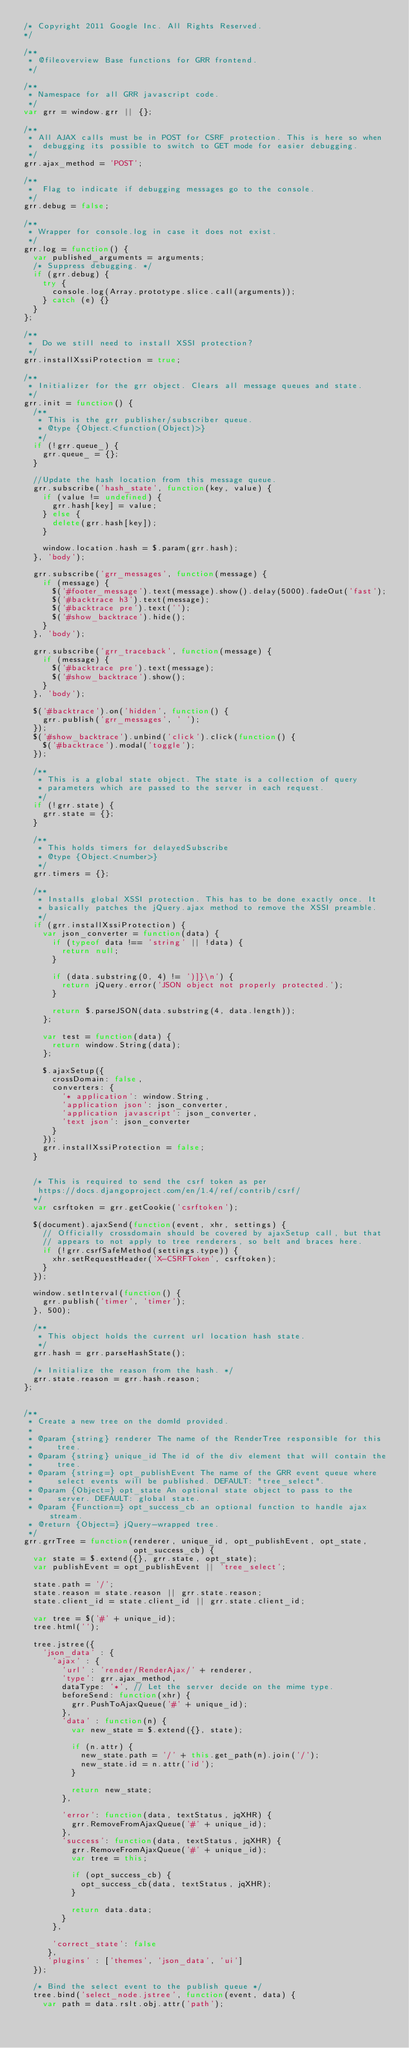<code> <loc_0><loc_0><loc_500><loc_500><_JavaScript_>/* Copyright 2011 Google Inc. All Rights Reserved.
*/

/**
 * @fileoverview Base functions for GRR frontend.
 */

/**
 * Namespace for all GRR javascript code.
 */
var grr = window.grr || {};

/**
 * All AJAX calls must be in POST for CSRF protection. This is here so when
 *  debugging its possible to switch to GET mode for easier debugging.
 */
grr.ajax_method = 'POST';

/**
 *  Flag to indicate if debugging messages go to the console.
 */
grr.debug = false;

/**
 * Wrapper for console.log in case it does not exist.
 */
grr.log = function() {
  var published_arguments = arguments;
  /* Suppress debugging. */
  if (grr.debug) {
    try {
      console.log(Array.prototype.slice.call(arguments));
    } catch (e) {}
  }
};

/**
 *  Do we still need to install XSSI protection?
 */
grr.installXssiProtection = true;

/**
 * Initializer for the grr object. Clears all message queues and state.
 */
grr.init = function() {
  /**
   * This is the grr publisher/subscriber queue.
   * @type {Object.<function(Object)>}
   */
  if (!grr.queue_) {
    grr.queue_ = {};
  }

  //Update the hash location from this message queue.
  grr.subscribe('hash_state', function(key, value) {
    if (value != undefined) {
      grr.hash[key] = value;
    } else {
      delete(grr.hash[key]);
    }

    window.location.hash = $.param(grr.hash);
  }, 'body');

  grr.subscribe('grr_messages', function(message) {
    if (message) {
      $('#footer_message').text(message).show().delay(5000).fadeOut('fast');
      $('#backtrace h3').text(message);
      $('#backtrace pre').text('');
      $('#show_backtrace').hide();
    }
  }, 'body');

  grr.subscribe('grr_traceback', function(message) {
    if (message) {
      $('#backtrace pre').text(message);
      $('#show_backtrace').show();
    }
  }, 'body');

  $('#backtrace').on('hidden', function() {
    grr.publish('grr_messages', ' ');
  });
  $('#show_backtrace').unbind('click').click(function() {
    $('#backtrace').modal('toggle');
  });

  /**
   * This is a global state object. The state is a collection of query
   * parameters which are passed to the server in each request.
   */
  if (!grr.state) {
    grr.state = {};
  }

  /**
   * This holds timers for delayedSubscribe
   * @type {Object.<number>}
   */
  grr.timers = {};

  /**
   * Installs global XSSI protection. This has to be done exactly once. It
   * basically patches the jQuery.ajax method to remove the XSSI preamble.
   */
  if (grr.installXssiProtection) {
    var json_converter = function(data) {
      if (typeof data !== 'string' || !data) {
        return null;
      }

      if (data.substring(0, 4) != ')]}\n') {
        return jQuery.error('JSON object not properly protected.');
      }

      return $.parseJSON(data.substring(4, data.length));
    };

    var test = function(data) {
      return window.String(data);
    };

    $.ajaxSetup({
      crossDomain: false,
      converters: {
        '* application': window.String,
        'application json': json_converter,
        'application javascript': json_converter,
        'text json': json_converter
      }
    });
    grr.installXssiProtection = false;
  }


  /* This is required to send the csrf token as per
   https://docs.djangoproject.com/en/1.4/ref/contrib/csrf/
  */
  var csrftoken = grr.getCookie('csrftoken');

  $(document).ajaxSend(function(event, xhr, settings) {
    // Officially crossdomain should be covered by ajaxSetup call, but that
    // appears to not apply to tree renderers, so belt and braces here.
    if (!grr.csrfSafeMethod(settings.type)) {
      xhr.setRequestHeader('X-CSRFToken', csrftoken);
    }
  });

  window.setInterval(function() {
    grr.publish('timer', 'timer');
  }, 500);

  /**
   * This object holds the current url location hash state.
   */
  grr.hash = grr.parseHashState();

  /* Initialize the reason from the hash. */
  grr.state.reason = grr.hash.reason;
};


/**
 * Create a new tree on the domId provided.
 *
 * @param {string} renderer The name of the RenderTree responsible for this
 *     tree.
 * @param {string} unique_id The id of the div element that will contain the
 *     tree.
 * @param {string=} opt_publishEvent The name of the GRR event queue where
 *     select events will be published. DEFAULT: "tree_select".
 * @param {Object=} opt_state An optional state object to pass to the
 *     server. DEFAULT: global state.
 * @param {Function=} opt_success_cb an optional function to handle ajax stream.
 * @return {Object=} jQuery-wrapped tree.
 */
grr.grrTree = function(renderer, unique_id, opt_publishEvent, opt_state,
                       opt_success_cb) {
  var state = $.extend({}, grr.state, opt_state);
  var publishEvent = opt_publishEvent || 'tree_select';

  state.path = '/';
  state.reason = state.reason || grr.state.reason;
  state.client_id = state.client_id || grr.state.client_id;

  var tree = $('#' + unique_id);
  tree.html('');

  tree.jstree({
    'json_data' : {
      'ajax' : {
        'url' : 'render/RenderAjax/' + renderer,
        'type': grr.ajax_method,
        dataType: '*', // Let the server decide on the mime type.
        beforeSend: function(xhr) {
          grr.PushToAjaxQueue('#' + unique_id);
        },
        'data' : function(n) {
          var new_state = $.extend({}, state);

          if (n.attr) {
            new_state.path = '/' + this.get_path(n).join('/');
            new_state.id = n.attr('id');
          }

          return new_state;
        },

        'error': function(data, textStatus, jqXHR) {
          grr.RemoveFromAjaxQueue('#' + unique_id);
        },
        'success': function(data, textStatus, jqXHR) {
          grr.RemoveFromAjaxQueue('#' + unique_id);
          var tree = this;

          if (opt_success_cb) {
            opt_success_cb(data, textStatus, jqXHR);
          }

          return data.data;
        }
      },

      'correct_state': false
     },
     'plugins' : ['themes', 'json_data', 'ui']
  });

  /* Bind the select event to the publish queue */
  tree.bind('select_node.jstree', function(event, data) {
    var path = data.rslt.obj.attr('path');</code> 